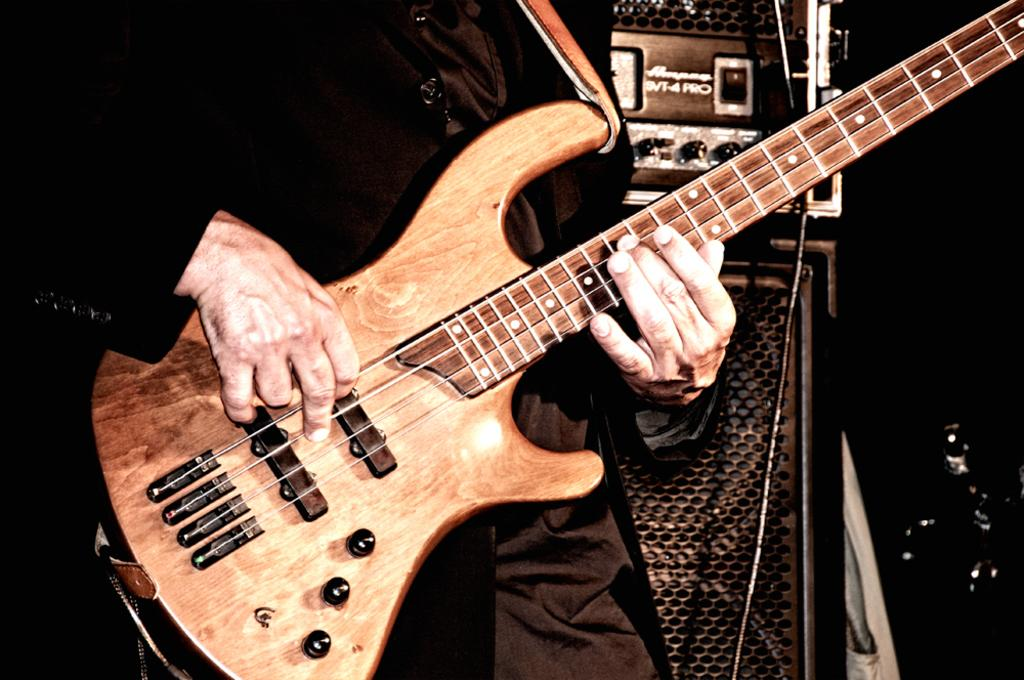What is the main subject of the image? There is a person in the image. What is the person doing in the image? The person is holding and playing a guitar. What is the person wearing in the image? The person is wearing clothes. What objects are visible behind the person? There are speakers behind the person. What type of protest is taking place in the image? There is no protest present in the image; it features a person playing a guitar with speakers behind them. 